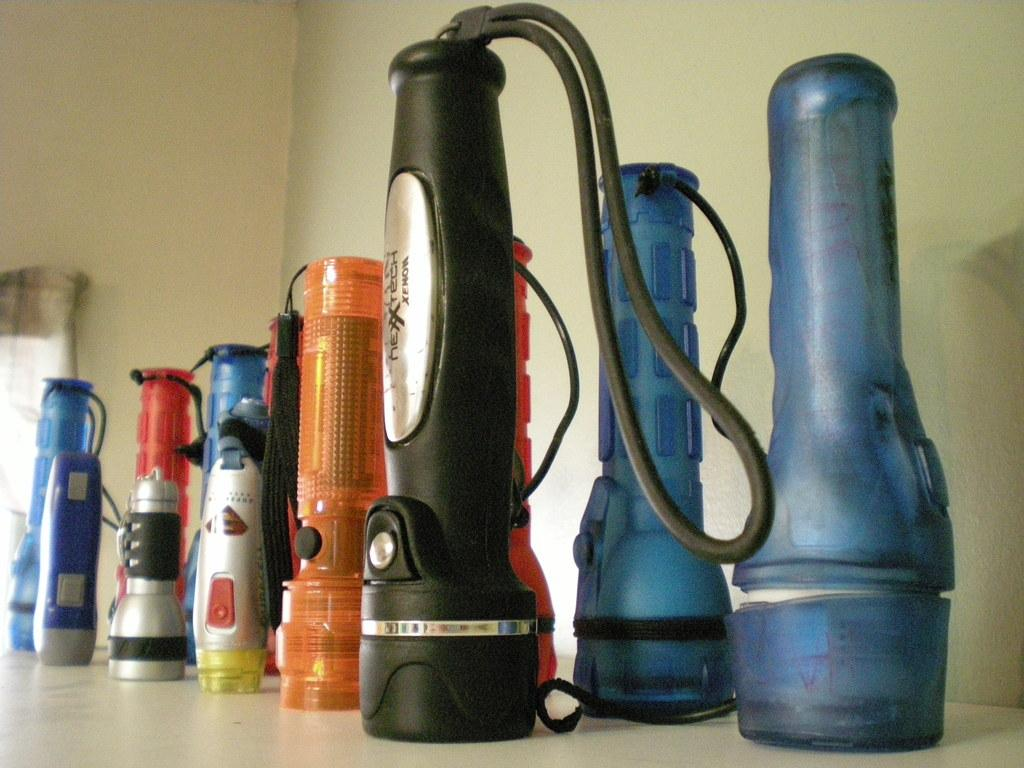What type of lighting is present in the image? There are torch lights in the image. What can be observed about the colors of the torch lights? The torch lights are in different colors. Where are the torch lights placed in the image? The torch lights are placed on the floor. What can be seen in the background of the image? There is a wall visible in the background of the image. What is the income of the person who owns the hall in the image? There is no information about a hall or the income of a person in the image. The image only features torch lights placed on the floor and a wall visible in the background. 